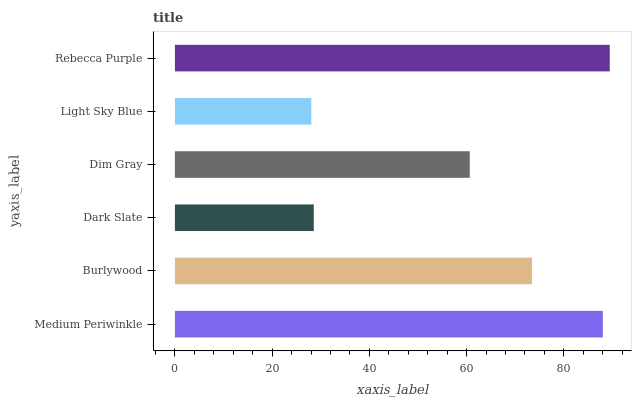Is Light Sky Blue the minimum?
Answer yes or no. Yes. Is Rebecca Purple the maximum?
Answer yes or no. Yes. Is Burlywood the minimum?
Answer yes or no. No. Is Burlywood the maximum?
Answer yes or no. No. Is Medium Periwinkle greater than Burlywood?
Answer yes or no. Yes. Is Burlywood less than Medium Periwinkle?
Answer yes or no. Yes. Is Burlywood greater than Medium Periwinkle?
Answer yes or no. No. Is Medium Periwinkle less than Burlywood?
Answer yes or no. No. Is Burlywood the high median?
Answer yes or no. Yes. Is Dim Gray the low median?
Answer yes or no. Yes. Is Rebecca Purple the high median?
Answer yes or no. No. Is Light Sky Blue the low median?
Answer yes or no. No. 